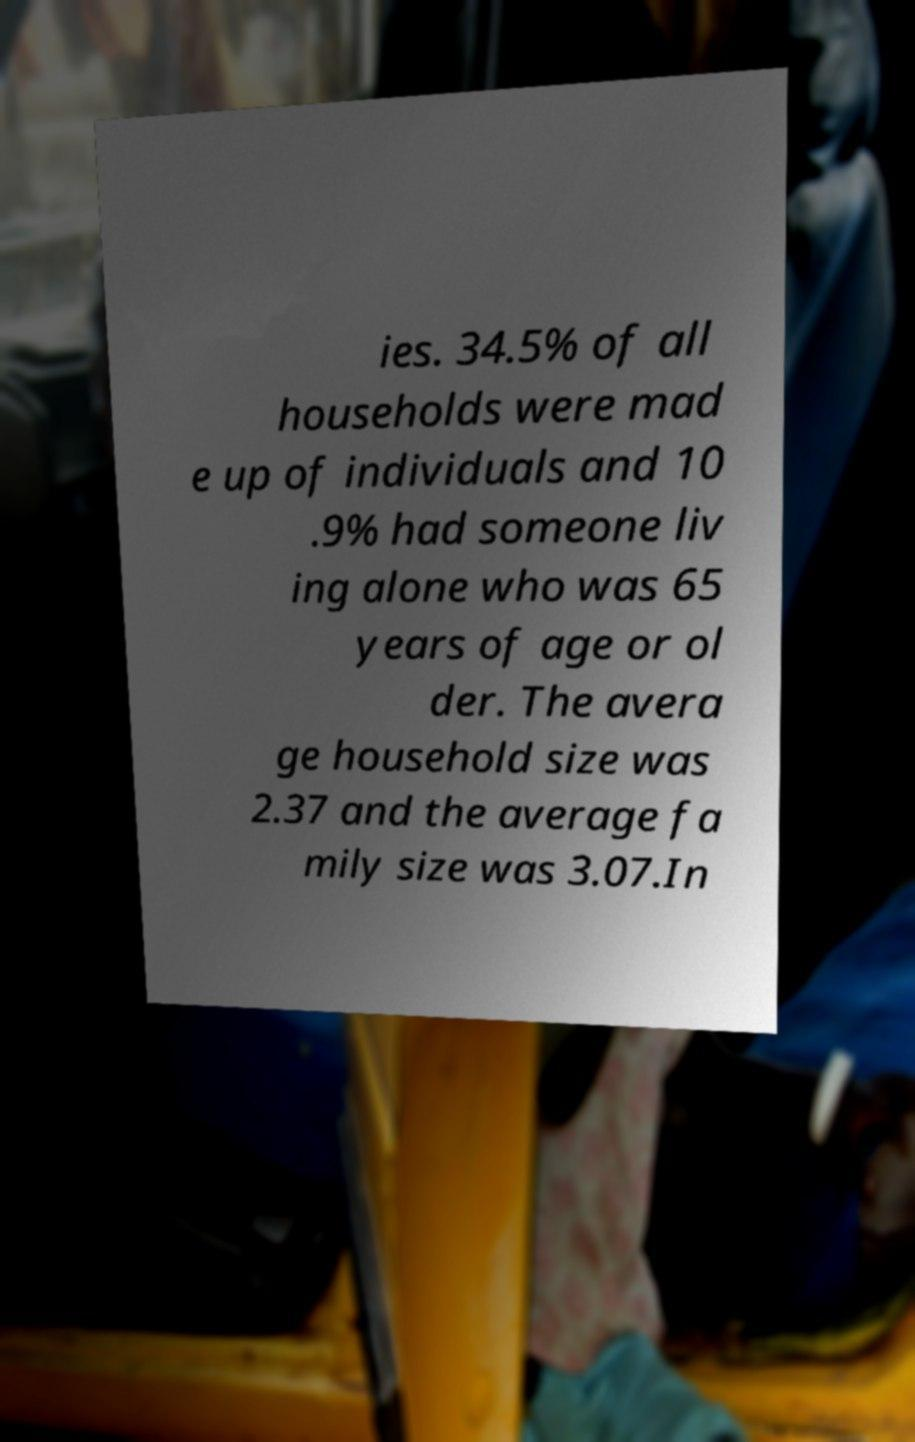Please identify and transcribe the text found in this image. ies. 34.5% of all households were mad e up of individuals and 10 .9% had someone liv ing alone who was 65 years of age or ol der. The avera ge household size was 2.37 and the average fa mily size was 3.07.In 